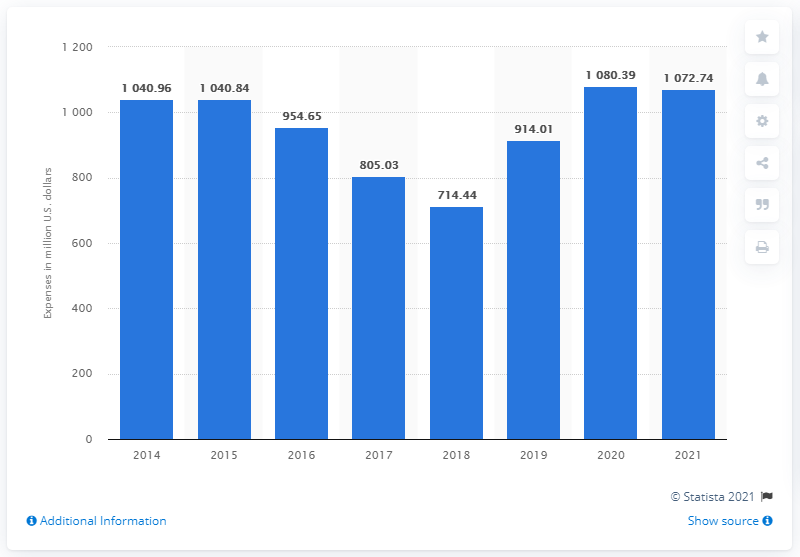Mention a couple of crucial points in this snapshot. In the 2021 fiscal year, Marvel spent 1072.74 on research and development. 